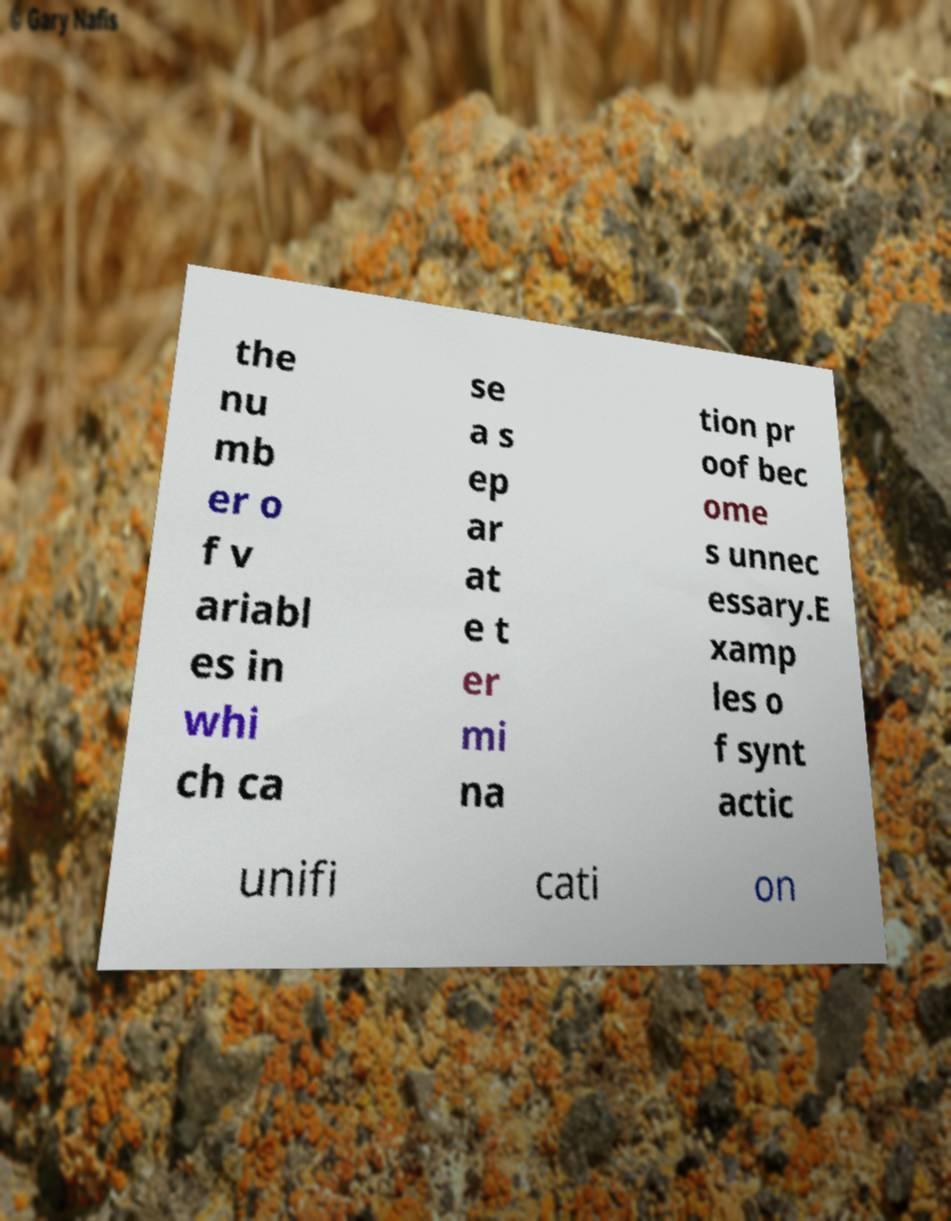Could you extract and type out the text from this image? the nu mb er o f v ariabl es in whi ch ca se a s ep ar at e t er mi na tion pr oof bec ome s unnec essary.E xamp les o f synt actic unifi cati on 